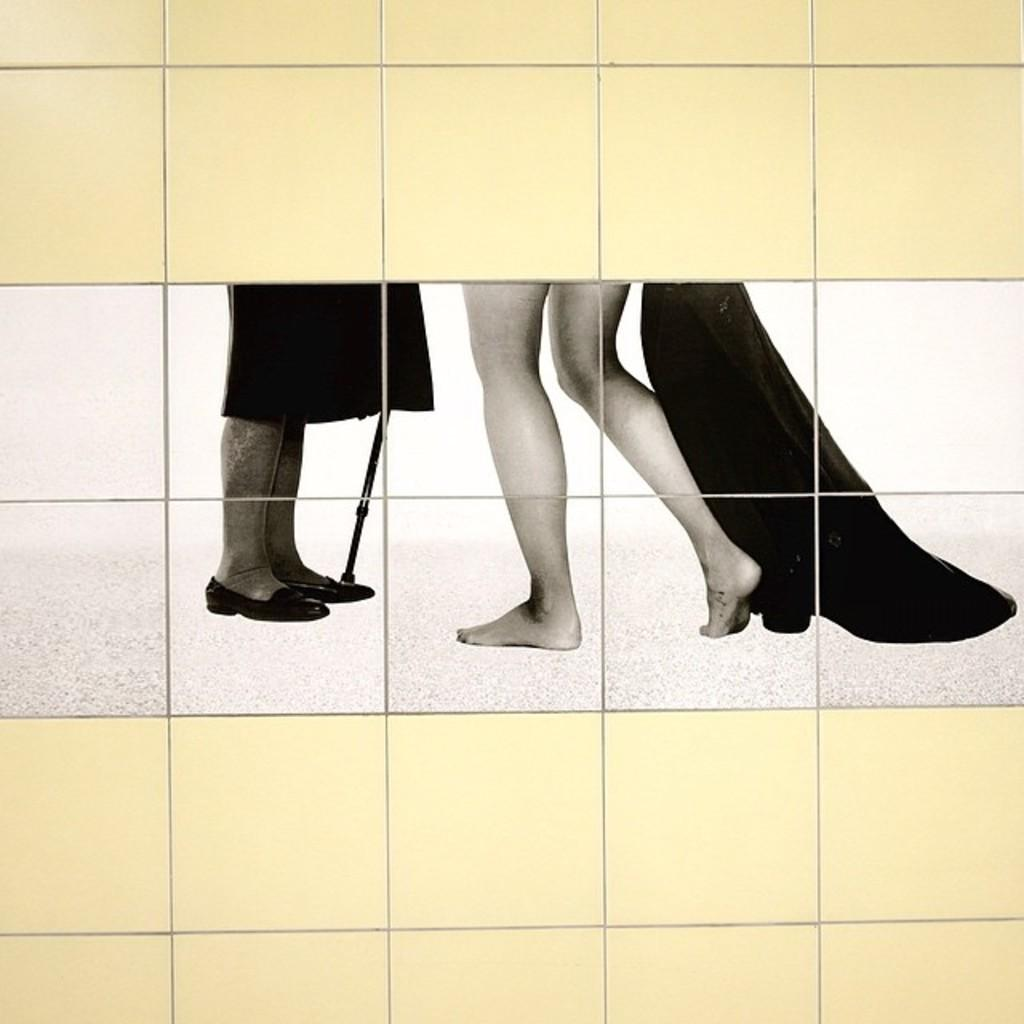What type of surface is visible in the image? There is a wall with tiles in the image. Can you describe what is happening on the wall? Two people's legs are visible on the wall. What else can be seen on the wall besides the legs? There is a stick and a cloth on the wall. What type of border is visible around the wall in the image? There is no border visible around the wall in the image. Can you provide a list of items that are not present in the image? It is not necessary to provide a list of items that are not present in the image, as the focus should be on the elements that are visible. 